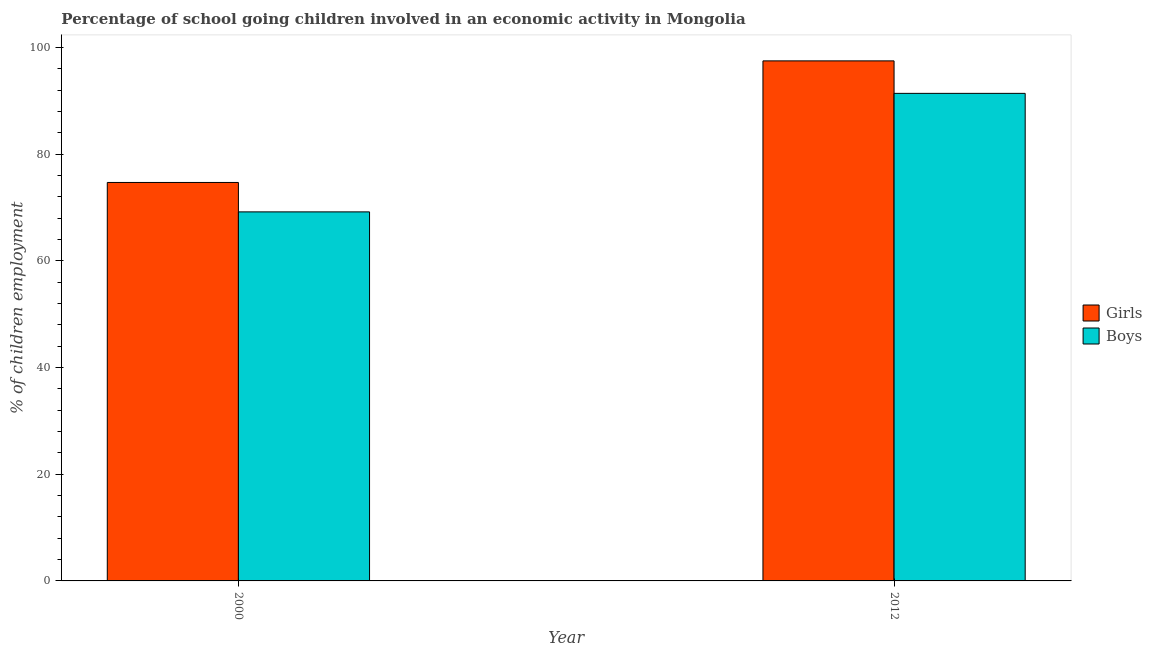How many groups of bars are there?
Offer a very short reply. 2. Are the number of bars per tick equal to the number of legend labels?
Give a very brief answer. Yes. Are the number of bars on each tick of the X-axis equal?
Keep it short and to the point. Yes. How many bars are there on the 2nd tick from the left?
Your answer should be compact. 2. How many bars are there on the 2nd tick from the right?
Make the answer very short. 2. What is the percentage of school going girls in 2000?
Your answer should be compact. 74.68. Across all years, what is the maximum percentage of school going boys?
Offer a terse response. 91.38. Across all years, what is the minimum percentage of school going girls?
Your answer should be compact. 74.68. In which year was the percentage of school going boys maximum?
Provide a succinct answer. 2012. In which year was the percentage of school going boys minimum?
Keep it short and to the point. 2000. What is the total percentage of school going boys in the graph?
Provide a short and direct response. 160.55. What is the difference between the percentage of school going girls in 2000 and that in 2012?
Give a very brief answer. -22.79. What is the difference between the percentage of school going boys in 2012 and the percentage of school going girls in 2000?
Your response must be concise. 22.21. What is the average percentage of school going boys per year?
Provide a short and direct response. 80.27. In the year 2012, what is the difference between the percentage of school going girls and percentage of school going boys?
Make the answer very short. 0. In how many years, is the percentage of school going boys greater than 84 %?
Offer a terse response. 1. What is the ratio of the percentage of school going boys in 2000 to that in 2012?
Provide a short and direct response. 0.76. Is the percentage of school going boys in 2000 less than that in 2012?
Your answer should be compact. Yes. In how many years, is the percentage of school going girls greater than the average percentage of school going girls taken over all years?
Your answer should be compact. 1. What does the 2nd bar from the left in 2012 represents?
Make the answer very short. Boys. What does the 1st bar from the right in 2000 represents?
Offer a terse response. Boys. Are all the bars in the graph horizontal?
Ensure brevity in your answer.  No. How many years are there in the graph?
Your answer should be very brief. 2. What is the difference between two consecutive major ticks on the Y-axis?
Offer a very short reply. 20. Are the values on the major ticks of Y-axis written in scientific E-notation?
Your answer should be compact. No. Does the graph contain any zero values?
Ensure brevity in your answer.  No. Where does the legend appear in the graph?
Make the answer very short. Center right. How are the legend labels stacked?
Give a very brief answer. Vertical. What is the title of the graph?
Your response must be concise. Percentage of school going children involved in an economic activity in Mongolia. What is the label or title of the X-axis?
Provide a short and direct response. Year. What is the label or title of the Y-axis?
Your response must be concise. % of children employment. What is the % of children employment in Girls in 2000?
Your response must be concise. 74.68. What is the % of children employment in Boys in 2000?
Provide a succinct answer. 69.17. What is the % of children employment in Girls in 2012?
Offer a terse response. 97.47. What is the % of children employment of Boys in 2012?
Offer a very short reply. 91.38. Across all years, what is the maximum % of children employment in Girls?
Provide a short and direct response. 97.47. Across all years, what is the maximum % of children employment of Boys?
Your answer should be compact. 91.38. Across all years, what is the minimum % of children employment in Girls?
Your answer should be very brief. 74.68. Across all years, what is the minimum % of children employment in Boys?
Make the answer very short. 69.17. What is the total % of children employment of Girls in the graph?
Offer a very short reply. 172.15. What is the total % of children employment of Boys in the graph?
Make the answer very short. 160.55. What is the difference between the % of children employment in Girls in 2000 and that in 2012?
Give a very brief answer. -22.79. What is the difference between the % of children employment in Boys in 2000 and that in 2012?
Offer a very short reply. -22.21. What is the difference between the % of children employment in Girls in 2000 and the % of children employment in Boys in 2012?
Your answer should be very brief. -16.7. What is the average % of children employment in Girls per year?
Your answer should be very brief. 86.08. What is the average % of children employment of Boys per year?
Offer a terse response. 80.27. In the year 2000, what is the difference between the % of children employment of Girls and % of children employment of Boys?
Offer a very short reply. 5.51. In the year 2012, what is the difference between the % of children employment of Girls and % of children employment of Boys?
Offer a very short reply. 6.09. What is the ratio of the % of children employment of Girls in 2000 to that in 2012?
Ensure brevity in your answer.  0.77. What is the ratio of the % of children employment of Boys in 2000 to that in 2012?
Keep it short and to the point. 0.76. What is the difference between the highest and the second highest % of children employment of Girls?
Your answer should be compact. 22.79. What is the difference between the highest and the second highest % of children employment of Boys?
Make the answer very short. 22.21. What is the difference between the highest and the lowest % of children employment in Girls?
Provide a succinct answer. 22.79. What is the difference between the highest and the lowest % of children employment in Boys?
Offer a terse response. 22.21. 